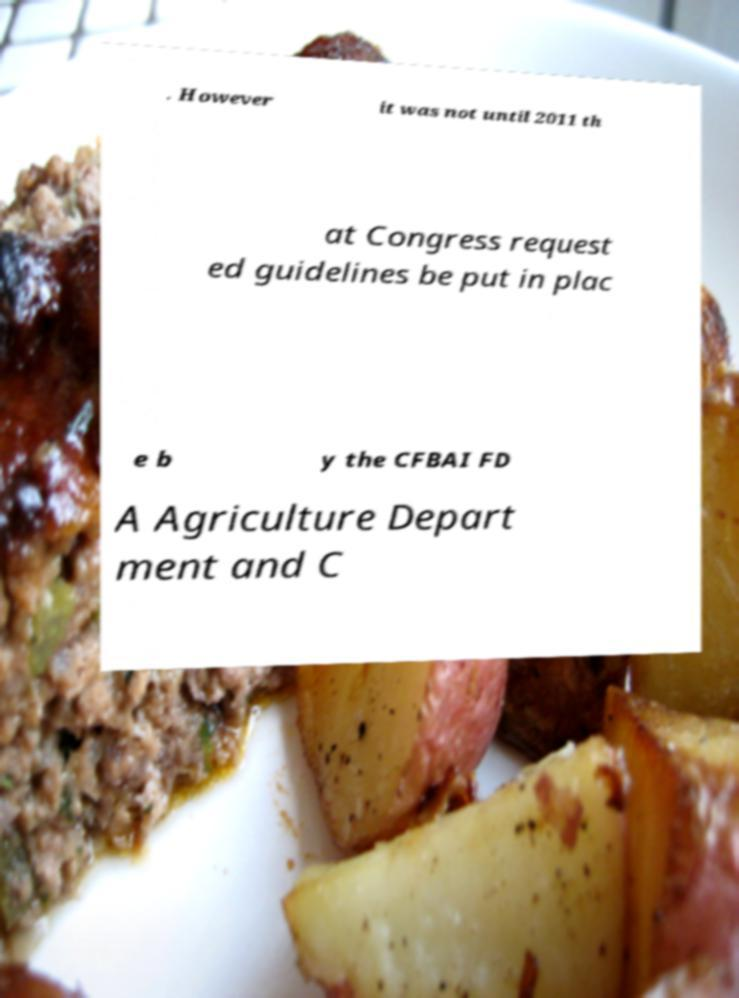Can you read and provide the text displayed in the image?This photo seems to have some interesting text. Can you extract and type it out for me? . However it was not until 2011 th at Congress request ed guidelines be put in plac e b y the CFBAI FD A Agriculture Depart ment and C 